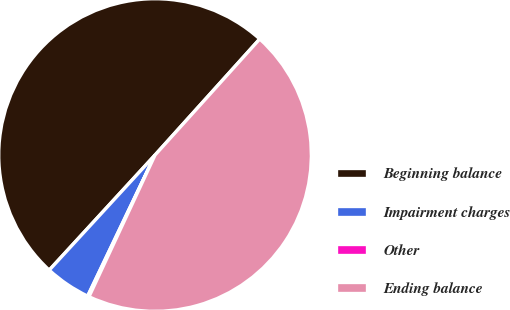Convert chart to OTSL. <chart><loc_0><loc_0><loc_500><loc_500><pie_chart><fcel>Beginning balance<fcel>Impairment charges<fcel>Other<fcel>Ending balance<nl><fcel>49.85%<fcel>4.74%<fcel>0.15%<fcel>45.26%<nl></chart> 